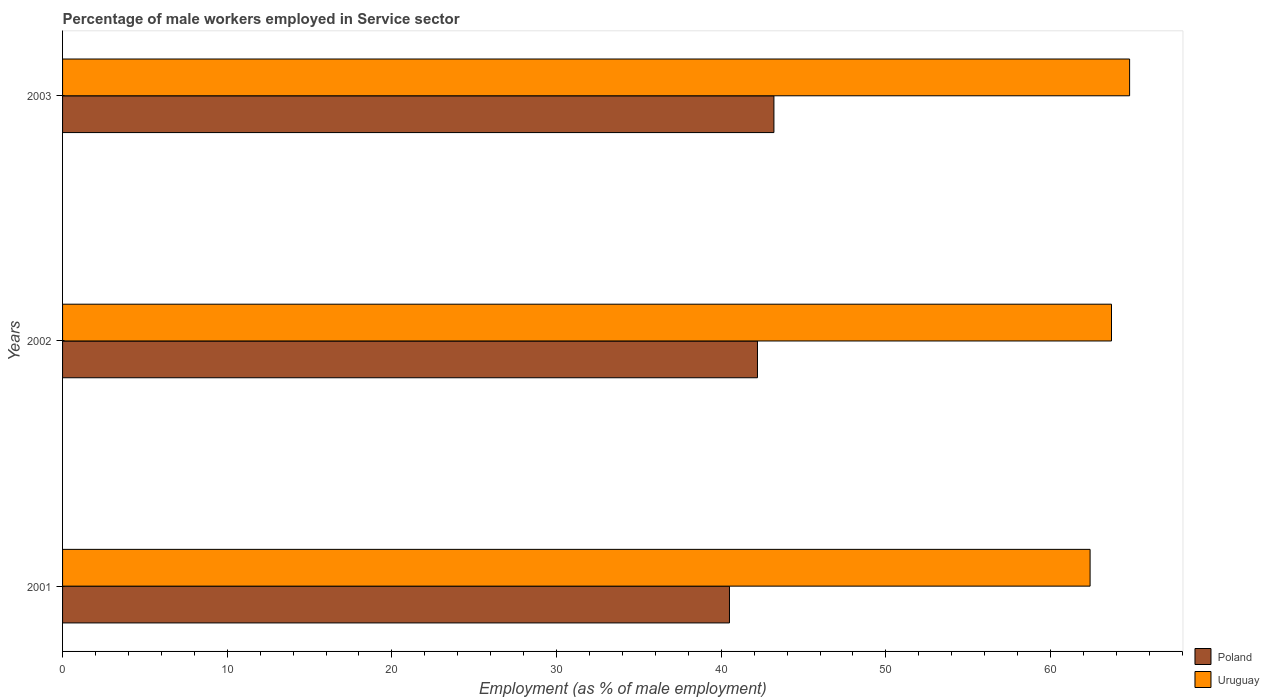How many different coloured bars are there?
Your answer should be compact. 2. How many groups of bars are there?
Give a very brief answer. 3. How many bars are there on the 2nd tick from the top?
Provide a succinct answer. 2. In how many cases, is the number of bars for a given year not equal to the number of legend labels?
Offer a terse response. 0. What is the percentage of male workers employed in Service sector in Uruguay in 2002?
Offer a terse response. 63.7. Across all years, what is the maximum percentage of male workers employed in Service sector in Poland?
Ensure brevity in your answer.  43.2. Across all years, what is the minimum percentage of male workers employed in Service sector in Poland?
Provide a short and direct response. 40.5. In which year was the percentage of male workers employed in Service sector in Poland maximum?
Offer a terse response. 2003. What is the total percentage of male workers employed in Service sector in Uruguay in the graph?
Keep it short and to the point. 190.9. What is the difference between the percentage of male workers employed in Service sector in Poland in 2002 and that in 2003?
Ensure brevity in your answer.  -1. What is the difference between the percentage of male workers employed in Service sector in Uruguay in 2001 and the percentage of male workers employed in Service sector in Poland in 2002?
Offer a terse response. 20.2. What is the average percentage of male workers employed in Service sector in Uruguay per year?
Provide a short and direct response. 63.63. In the year 2002, what is the difference between the percentage of male workers employed in Service sector in Uruguay and percentage of male workers employed in Service sector in Poland?
Offer a very short reply. 21.5. What is the ratio of the percentage of male workers employed in Service sector in Uruguay in 2001 to that in 2002?
Provide a short and direct response. 0.98. Is the difference between the percentage of male workers employed in Service sector in Uruguay in 2001 and 2002 greater than the difference between the percentage of male workers employed in Service sector in Poland in 2001 and 2002?
Provide a succinct answer. Yes. What is the difference between the highest and the second highest percentage of male workers employed in Service sector in Poland?
Keep it short and to the point. 1. What is the difference between the highest and the lowest percentage of male workers employed in Service sector in Poland?
Ensure brevity in your answer.  2.7. Is the sum of the percentage of male workers employed in Service sector in Uruguay in 2001 and 2002 greater than the maximum percentage of male workers employed in Service sector in Poland across all years?
Your answer should be very brief. Yes. What does the 1st bar from the top in 2001 represents?
Your answer should be very brief. Uruguay. How many bars are there?
Your answer should be very brief. 6. Are all the bars in the graph horizontal?
Make the answer very short. Yes. How many years are there in the graph?
Give a very brief answer. 3. Are the values on the major ticks of X-axis written in scientific E-notation?
Make the answer very short. No. Does the graph contain any zero values?
Your response must be concise. No. Does the graph contain grids?
Your response must be concise. No. Where does the legend appear in the graph?
Make the answer very short. Bottom right. How many legend labels are there?
Keep it short and to the point. 2. How are the legend labels stacked?
Make the answer very short. Vertical. What is the title of the graph?
Ensure brevity in your answer.  Percentage of male workers employed in Service sector. What is the label or title of the X-axis?
Provide a short and direct response. Employment (as % of male employment). What is the label or title of the Y-axis?
Your answer should be very brief. Years. What is the Employment (as % of male employment) in Poland in 2001?
Your answer should be compact. 40.5. What is the Employment (as % of male employment) in Uruguay in 2001?
Keep it short and to the point. 62.4. What is the Employment (as % of male employment) of Poland in 2002?
Provide a short and direct response. 42.2. What is the Employment (as % of male employment) in Uruguay in 2002?
Your answer should be compact. 63.7. What is the Employment (as % of male employment) in Poland in 2003?
Your answer should be very brief. 43.2. What is the Employment (as % of male employment) of Uruguay in 2003?
Keep it short and to the point. 64.8. Across all years, what is the maximum Employment (as % of male employment) in Poland?
Your answer should be very brief. 43.2. Across all years, what is the maximum Employment (as % of male employment) in Uruguay?
Make the answer very short. 64.8. Across all years, what is the minimum Employment (as % of male employment) in Poland?
Offer a terse response. 40.5. Across all years, what is the minimum Employment (as % of male employment) of Uruguay?
Offer a very short reply. 62.4. What is the total Employment (as % of male employment) in Poland in the graph?
Keep it short and to the point. 125.9. What is the total Employment (as % of male employment) in Uruguay in the graph?
Ensure brevity in your answer.  190.9. What is the difference between the Employment (as % of male employment) in Poland in 2001 and that in 2002?
Your response must be concise. -1.7. What is the difference between the Employment (as % of male employment) in Uruguay in 2001 and that in 2003?
Provide a succinct answer. -2.4. What is the difference between the Employment (as % of male employment) in Poland in 2001 and the Employment (as % of male employment) in Uruguay in 2002?
Provide a short and direct response. -23.2. What is the difference between the Employment (as % of male employment) in Poland in 2001 and the Employment (as % of male employment) in Uruguay in 2003?
Provide a short and direct response. -24.3. What is the difference between the Employment (as % of male employment) in Poland in 2002 and the Employment (as % of male employment) in Uruguay in 2003?
Offer a very short reply. -22.6. What is the average Employment (as % of male employment) of Poland per year?
Keep it short and to the point. 41.97. What is the average Employment (as % of male employment) in Uruguay per year?
Your answer should be very brief. 63.63. In the year 2001, what is the difference between the Employment (as % of male employment) of Poland and Employment (as % of male employment) of Uruguay?
Ensure brevity in your answer.  -21.9. In the year 2002, what is the difference between the Employment (as % of male employment) of Poland and Employment (as % of male employment) of Uruguay?
Your answer should be very brief. -21.5. In the year 2003, what is the difference between the Employment (as % of male employment) of Poland and Employment (as % of male employment) of Uruguay?
Your answer should be very brief. -21.6. What is the ratio of the Employment (as % of male employment) in Poland in 2001 to that in 2002?
Your response must be concise. 0.96. What is the ratio of the Employment (as % of male employment) in Uruguay in 2001 to that in 2002?
Your response must be concise. 0.98. What is the ratio of the Employment (as % of male employment) of Poland in 2001 to that in 2003?
Your answer should be compact. 0.94. What is the ratio of the Employment (as % of male employment) of Uruguay in 2001 to that in 2003?
Offer a very short reply. 0.96. What is the ratio of the Employment (as % of male employment) of Poland in 2002 to that in 2003?
Make the answer very short. 0.98. What is the difference between the highest and the second highest Employment (as % of male employment) of Poland?
Make the answer very short. 1. What is the difference between the highest and the second highest Employment (as % of male employment) of Uruguay?
Offer a very short reply. 1.1. What is the difference between the highest and the lowest Employment (as % of male employment) in Uruguay?
Provide a succinct answer. 2.4. 